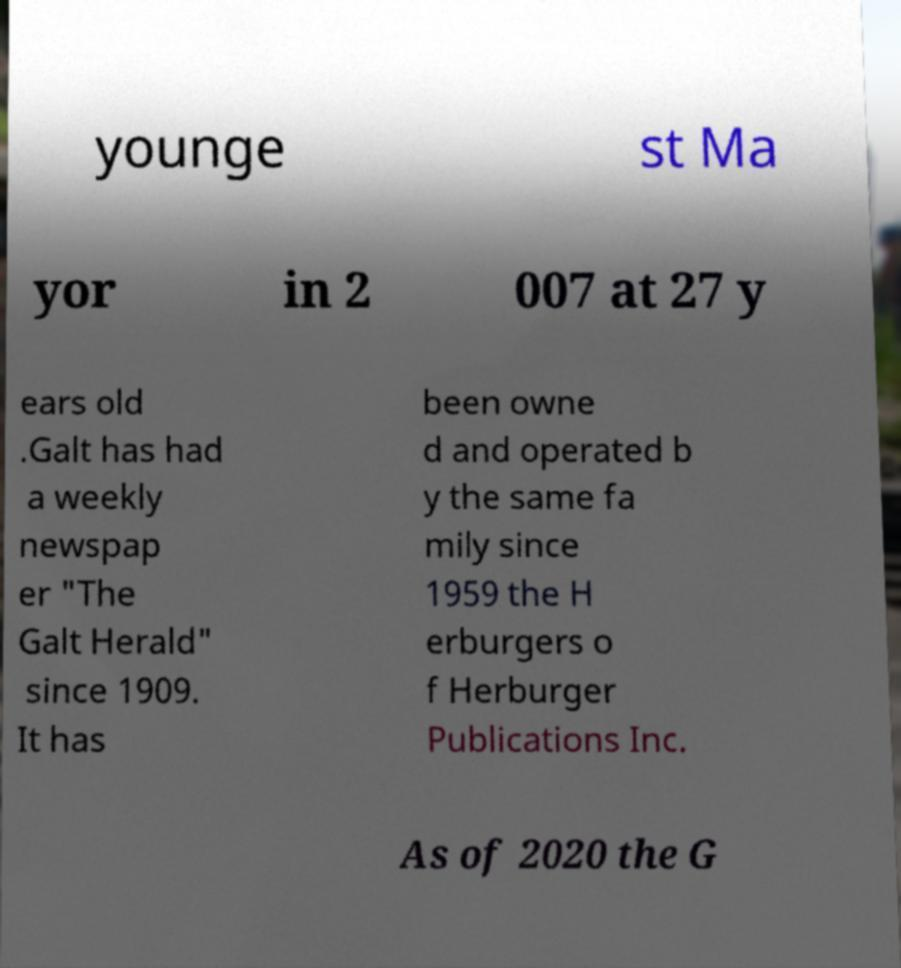Please identify and transcribe the text found in this image. younge st Ma yor in 2 007 at 27 y ears old .Galt has had a weekly newspap er "The Galt Herald" since 1909. It has been owne d and operated b y the same fa mily since 1959 the H erburgers o f Herburger Publications Inc. As of 2020 the G 